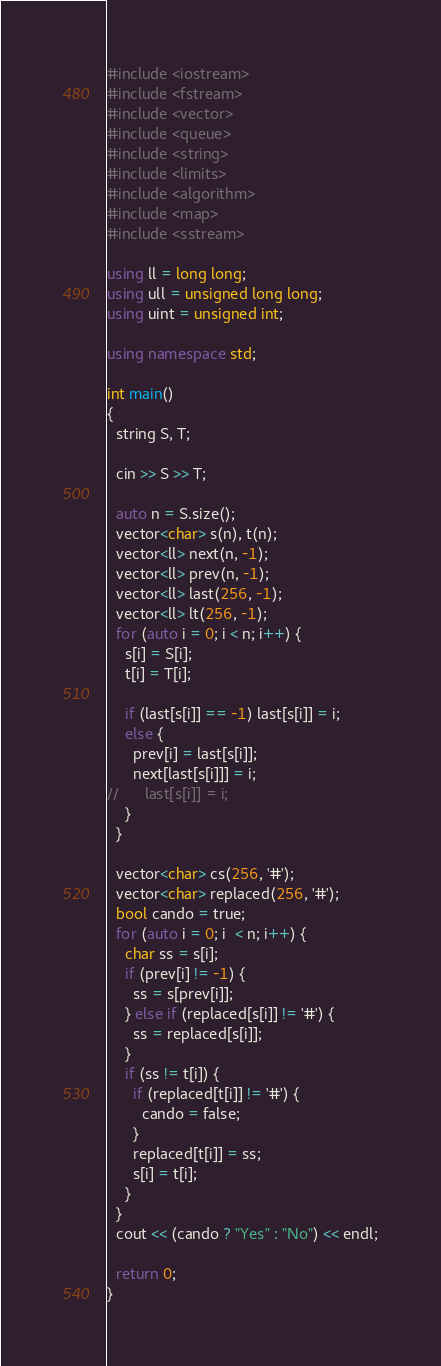<code> <loc_0><loc_0><loc_500><loc_500><_C++_>#include <iostream>
#include <fstream>
#include <vector>
#include <queue>
#include <string>
#include <limits>
#include <algorithm>
#include <map>
#include <sstream>

using ll = long long;
using ull = unsigned long long;
using uint = unsigned int;

using namespace std;

int main()
{
  string S, T;

  cin >> S >> T;

  auto n = S.size();
  vector<char> s(n), t(n);
  vector<ll> next(n, -1);
  vector<ll> prev(n, -1);
  vector<ll> last(256, -1);
  vector<ll> lt(256, -1);
  for (auto i = 0; i < n; i++) {
    s[i] = S[i];
    t[i] = T[i];

    if (last[s[i]] == -1) last[s[i]] = i;
    else {
      prev[i] = last[s[i]];
      next[last[s[i]]] = i;
//      last[s[i]] = i;
    }
  }

  vector<char> cs(256, '#');
  vector<char> replaced(256, '#');
  bool cando = true;
  for (auto i = 0; i  < n; i++) {
    char ss = s[i];
    if (prev[i] != -1) {
      ss = s[prev[i]];
    } else if (replaced[s[i]] != '#') {
      ss = replaced[s[i]];
    }
    if (ss != t[i]) {
      if (replaced[t[i]] != '#') {
        cando = false;
      }
      replaced[t[i]] = ss;
      s[i] = t[i];
    }
  }
  cout << (cando ? "Yes" : "No") << endl;

  return 0;
}
</code> 